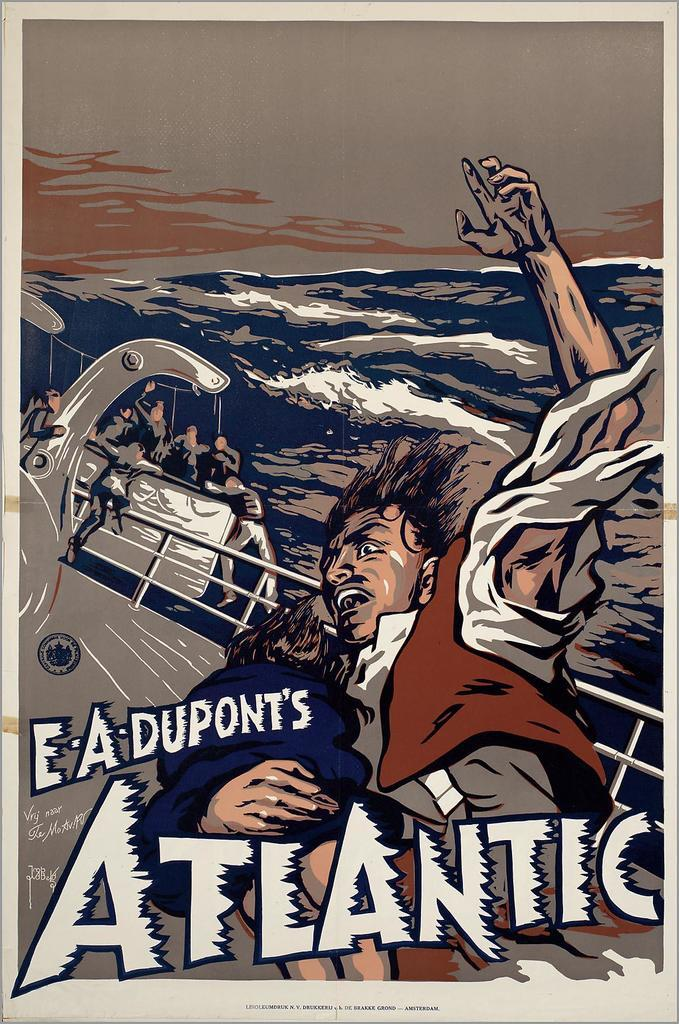<image>
Describe the image concisely. A poster shows an illustration of a ship on the Atlantic Ocean on a rough day. 